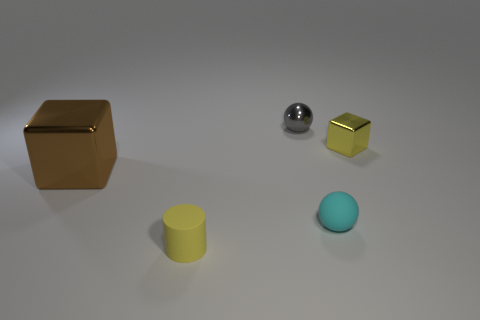Add 1 tiny brown metal cubes. How many objects exist? 6 Subtract all cylinders. How many objects are left? 4 Add 5 tiny red matte cubes. How many tiny red matte cubes exist? 5 Subtract 1 yellow cylinders. How many objects are left? 4 Subtract all tiny blue rubber cylinders. Subtract all tiny yellow cubes. How many objects are left? 4 Add 2 small cyan spheres. How many small cyan spheres are left? 3 